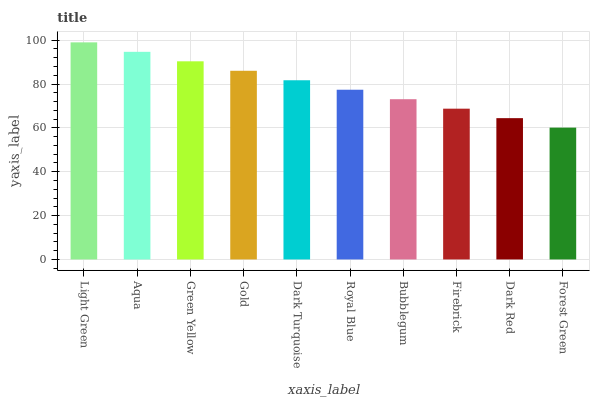Is Forest Green the minimum?
Answer yes or no. Yes. Is Light Green the maximum?
Answer yes or no. Yes. Is Aqua the minimum?
Answer yes or no. No. Is Aqua the maximum?
Answer yes or no. No. Is Light Green greater than Aqua?
Answer yes or no. Yes. Is Aqua less than Light Green?
Answer yes or no. Yes. Is Aqua greater than Light Green?
Answer yes or no. No. Is Light Green less than Aqua?
Answer yes or no. No. Is Dark Turquoise the high median?
Answer yes or no. Yes. Is Royal Blue the low median?
Answer yes or no. Yes. Is Firebrick the high median?
Answer yes or no. No. Is Light Green the low median?
Answer yes or no. No. 